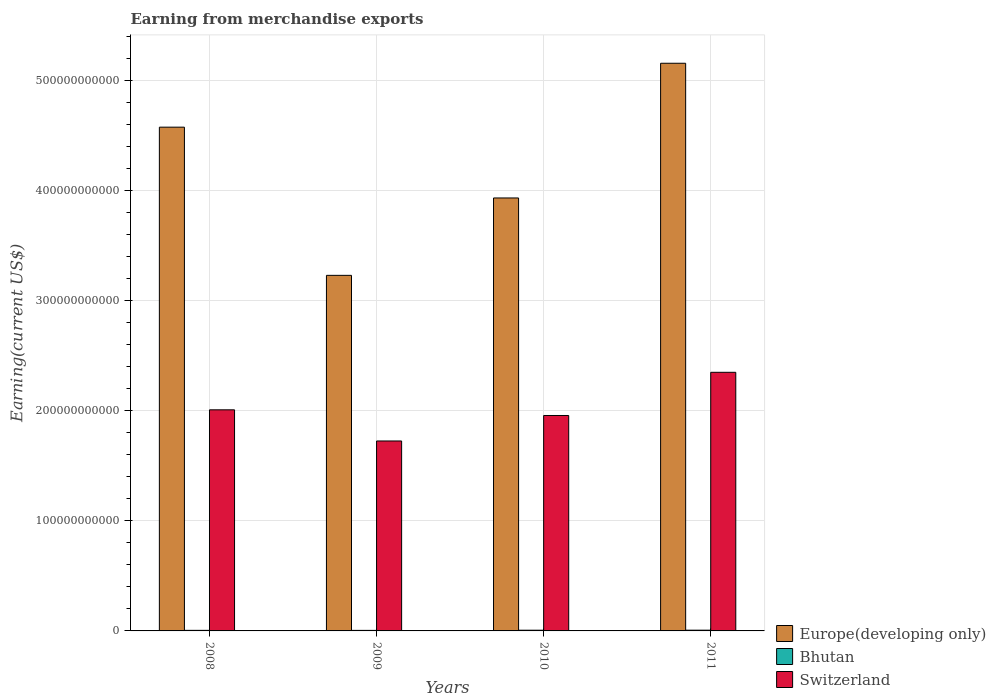Are the number of bars on each tick of the X-axis equal?
Your answer should be very brief. Yes. How many bars are there on the 2nd tick from the left?
Give a very brief answer. 3. How many bars are there on the 1st tick from the right?
Offer a terse response. 3. What is the label of the 2nd group of bars from the left?
Ensure brevity in your answer.  2009. In how many cases, is the number of bars for a given year not equal to the number of legend labels?
Keep it short and to the point. 0. What is the amount earned from merchandise exports in Europe(developing only) in 2010?
Your answer should be compact. 3.93e+11. Across all years, what is the maximum amount earned from merchandise exports in Bhutan?
Make the answer very short. 6.75e+08. Across all years, what is the minimum amount earned from merchandise exports in Bhutan?
Offer a very short reply. 4.96e+08. In which year was the amount earned from merchandise exports in Bhutan maximum?
Your answer should be compact. 2011. In which year was the amount earned from merchandise exports in Switzerland minimum?
Keep it short and to the point. 2009. What is the total amount earned from merchandise exports in Europe(developing only) in the graph?
Offer a very short reply. 1.69e+12. What is the difference between the amount earned from merchandise exports in Switzerland in 2008 and that in 2009?
Provide a succinct answer. 2.83e+1. What is the difference between the amount earned from merchandise exports in Bhutan in 2011 and the amount earned from merchandise exports in Switzerland in 2010?
Your response must be concise. -1.95e+11. What is the average amount earned from merchandise exports in Bhutan per year?
Offer a very short reply. 5.83e+08. In the year 2009, what is the difference between the amount earned from merchandise exports in Europe(developing only) and amount earned from merchandise exports in Bhutan?
Offer a terse response. 3.22e+11. In how many years, is the amount earned from merchandise exports in Europe(developing only) greater than 240000000000 US$?
Provide a short and direct response. 4. What is the ratio of the amount earned from merchandise exports in Bhutan in 2008 to that in 2009?
Offer a terse response. 1.05. What is the difference between the highest and the second highest amount earned from merchandise exports in Switzerland?
Ensure brevity in your answer.  3.41e+1. What is the difference between the highest and the lowest amount earned from merchandise exports in Europe(developing only)?
Make the answer very short. 1.93e+11. What does the 2nd bar from the left in 2008 represents?
Your answer should be compact. Bhutan. What does the 1st bar from the right in 2010 represents?
Give a very brief answer. Switzerland. How many years are there in the graph?
Your answer should be very brief. 4. What is the difference between two consecutive major ticks on the Y-axis?
Offer a very short reply. 1.00e+11. Where does the legend appear in the graph?
Provide a succinct answer. Bottom right. How many legend labels are there?
Provide a succinct answer. 3. How are the legend labels stacked?
Ensure brevity in your answer.  Vertical. What is the title of the graph?
Provide a short and direct response. Earning from merchandise exports. What is the label or title of the X-axis?
Your answer should be compact. Years. What is the label or title of the Y-axis?
Provide a short and direct response. Earning(current US$). What is the Earning(current US$) of Europe(developing only) in 2008?
Give a very brief answer. 4.57e+11. What is the Earning(current US$) in Bhutan in 2008?
Ensure brevity in your answer.  5.21e+08. What is the Earning(current US$) in Switzerland in 2008?
Your answer should be compact. 2.01e+11. What is the Earning(current US$) of Europe(developing only) in 2009?
Keep it short and to the point. 3.23e+11. What is the Earning(current US$) in Bhutan in 2009?
Offer a terse response. 4.96e+08. What is the Earning(current US$) in Switzerland in 2009?
Offer a very short reply. 1.72e+11. What is the Earning(current US$) in Europe(developing only) in 2010?
Your answer should be very brief. 3.93e+11. What is the Earning(current US$) of Bhutan in 2010?
Offer a very short reply. 6.41e+08. What is the Earning(current US$) in Switzerland in 2010?
Your answer should be compact. 1.96e+11. What is the Earning(current US$) in Europe(developing only) in 2011?
Provide a succinct answer. 5.15e+11. What is the Earning(current US$) of Bhutan in 2011?
Provide a short and direct response. 6.75e+08. What is the Earning(current US$) in Switzerland in 2011?
Ensure brevity in your answer.  2.35e+11. Across all years, what is the maximum Earning(current US$) of Europe(developing only)?
Your answer should be compact. 5.15e+11. Across all years, what is the maximum Earning(current US$) of Bhutan?
Give a very brief answer. 6.75e+08. Across all years, what is the maximum Earning(current US$) of Switzerland?
Provide a short and direct response. 2.35e+11. Across all years, what is the minimum Earning(current US$) in Europe(developing only)?
Your answer should be compact. 3.23e+11. Across all years, what is the minimum Earning(current US$) in Bhutan?
Offer a terse response. 4.96e+08. Across all years, what is the minimum Earning(current US$) in Switzerland?
Provide a short and direct response. 1.72e+11. What is the total Earning(current US$) of Europe(developing only) in the graph?
Offer a terse response. 1.69e+12. What is the total Earning(current US$) of Bhutan in the graph?
Your answer should be compact. 2.33e+09. What is the total Earning(current US$) of Switzerland in the graph?
Give a very brief answer. 8.04e+11. What is the difference between the Earning(current US$) in Europe(developing only) in 2008 and that in 2009?
Ensure brevity in your answer.  1.35e+11. What is the difference between the Earning(current US$) of Bhutan in 2008 and that in 2009?
Your answer should be compact. 2.56e+07. What is the difference between the Earning(current US$) of Switzerland in 2008 and that in 2009?
Your response must be concise. 2.83e+1. What is the difference between the Earning(current US$) in Europe(developing only) in 2008 and that in 2010?
Provide a succinct answer. 6.43e+1. What is the difference between the Earning(current US$) of Bhutan in 2008 and that in 2010?
Provide a short and direct response. -1.20e+08. What is the difference between the Earning(current US$) of Switzerland in 2008 and that in 2010?
Keep it short and to the point. 5.15e+09. What is the difference between the Earning(current US$) in Europe(developing only) in 2008 and that in 2011?
Ensure brevity in your answer.  -5.80e+1. What is the difference between the Earning(current US$) of Bhutan in 2008 and that in 2011?
Give a very brief answer. -1.53e+08. What is the difference between the Earning(current US$) of Switzerland in 2008 and that in 2011?
Make the answer very short. -3.41e+1. What is the difference between the Earning(current US$) of Europe(developing only) in 2009 and that in 2010?
Provide a succinct answer. -7.03e+1. What is the difference between the Earning(current US$) of Bhutan in 2009 and that in 2010?
Make the answer very short. -1.45e+08. What is the difference between the Earning(current US$) of Switzerland in 2009 and that in 2010?
Keep it short and to the point. -2.31e+1. What is the difference between the Earning(current US$) in Europe(developing only) in 2009 and that in 2011?
Keep it short and to the point. -1.93e+11. What is the difference between the Earning(current US$) in Bhutan in 2009 and that in 2011?
Your answer should be very brief. -1.79e+08. What is the difference between the Earning(current US$) of Switzerland in 2009 and that in 2011?
Give a very brief answer. -6.23e+1. What is the difference between the Earning(current US$) of Europe(developing only) in 2010 and that in 2011?
Provide a succinct answer. -1.22e+11. What is the difference between the Earning(current US$) in Bhutan in 2010 and that in 2011?
Provide a short and direct response. -3.33e+07. What is the difference between the Earning(current US$) of Switzerland in 2010 and that in 2011?
Provide a short and direct response. -3.92e+1. What is the difference between the Earning(current US$) of Europe(developing only) in 2008 and the Earning(current US$) of Bhutan in 2009?
Keep it short and to the point. 4.57e+11. What is the difference between the Earning(current US$) in Europe(developing only) in 2008 and the Earning(current US$) in Switzerland in 2009?
Your response must be concise. 2.85e+11. What is the difference between the Earning(current US$) in Bhutan in 2008 and the Earning(current US$) in Switzerland in 2009?
Make the answer very short. -1.72e+11. What is the difference between the Earning(current US$) in Europe(developing only) in 2008 and the Earning(current US$) in Bhutan in 2010?
Offer a very short reply. 4.57e+11. What is the difference between the Earning(current US$) of Europe(developing only) in 2008 and the Earning(current US$) of Switzerland in 2010?
Your answer should be very brief. 2.62e+11. What is the difference between the Earning(current US$) of Bhutan in 2008 and the Earning(current US$) of Switzerland in 2010?
Your answer should be compact. -1.95e+11. What is the difference between the Earning(current US$) of Europe(developing only) in 2008 and the Earning(current US$) of Bhutan in 2011?
Offer a very short reply. 4.57e+11. What is the difference between the Earning(current US$) in Europe(developing only) in 2008 and the Earning(current US$) in Switzerland in 2011?
Provide a short and direct response. 2.23e+11. What is the difference between the Earning(current US$) of Bhutan in 2008 and the Earning(current US$) of Switzerland in 2011?
Keep it short and to the point. -2.34e+11. What is the difference between the Earning(current US$) in Europe(developing only) in 2009 and the Earning(current US$) in Bhutan in 2010?
Give a very brief answer. 3.22e+11. What is the difference between the Earning(current US$) in Europe(developing only) in 2009 and the Earning(current US$) in Switzerland in 2010?
Offer a terse response. 1.27e+11. What is the difference between the Earning(current US$) of Bhutan in 2009 and the Earning(current US$) of Switzerland in 2010?
Your answer should be very brief. -1.95e+11. What is the difference between the Earning(current US$) in Europe(developing only) in 2009 and the Earning(current US$) in Bhutan in 2011?
Your answer should be very brief. 3.22e+11. What is the difference between the Earning(current US$) in Europe(developing only) in 2009 and the Earning(current US$) in Switzerland in 2011?
Offer a very short reply. 8.80e+1. What is the difference between the Earning(current US$) in Bhutan in 2009 and the Earning(current US$) in Switzerland in 2011?
Keep it short and to the point. -2.34e+11. What is the difference between the Earning(current US$) of Europe(developing only) in 2010 and the Earning(current US$) of Bhutan in 2011?
Keep it short and to the point. 3.92e+11. What is the difference between the Earning(current US$) in Europe(developing only) in 2010 and the Earning(current US$) in Switzerland in 2011?
Keep it short and to the point. 1.58e+11. What is the difference between the Earning(current US$) in Bhutan in 2010 and the Earning(current US$) in Switzerland in 2011?
Offer a very short reply. -2.34e+11. What is the average Earning(current US$) in Europe(developing only) per year?
Make the answer very short. 4.22e+11. What is the average Earning(current US$) in Bhutan per year?
Make the answer very short. 5.83e+08. What is the average Earning(current US$) in Switzerland per year?
Provide a short and direct response. 2.01e+11. In the year 2008, what is the difference between the Earning(current US$) in Europe(developing only) and Earning(current US$) in Bhutan?
Keep it short and to the point. 4.57e+11. In the year 2008, what is the difference between the Earning(current US$) in Europe(developing only) and Earning(current US$) in Switzerland?
Your answer should be compact. 2.57e+11. In the year 2008, what is the difference between the Earning(current US$) in Bhutan and Earning(current US$) in Switzerland?
Offer a terse response. -2.00e+11. In the year 2009, what is the difference between the Earning(current US$) in Europe(developing only) and Earning(current US$) in Bhutan?
Provide a succinct answer. 3.22e+11. In the year 2009, what is the difference between the Earning(current US$) in Europe(developing only) and Earning(current US$) in Switzerland?
Offer a terse response. 1.50e+11. In the year 2009, what is the difference between the Earning(current US$) in Bhutan and Earning(current US$) in Switzerland?
Make the answer very short. -1.72e+11. In the year 2010, what is the difference between the Earning(current US$) in Europe(developing only) and Earning(current US$) in Bhutan?
Ensure brevity in your answer.  3.92e+11. In the year 2010, what is the difference between the Earning(current US$) in Europe(developing only) and Earning(current US$) in Switzerland?
Keep it short and to the point. 1.98e+11. In the year 2010, what is the difference between the Earning(current US$) in Bhutan and Earning(current US$) in Switzerland?
Your response must be concise. -1.95e+11. In the year 2011, what is the difference between the Earning(current US$) of Europe(developing only) and Earning(current US$) of Bhutan?
Keep it short and to the point. 5.15e+11. In the year 2011, what is the difference between the Earning(current US$) in Europe(developing only) and Earning(current US$) in Switzerland?
Keep it short and to the point. 2.81e+11. In the year 2011, what is the difference between the Earning(current US$) of Bhutan and Earning(current US$) of Switzerland?
Your answer should be very brief. -2.34e+11. What is the ratio of the Earning(current US$) in Europe(developing only) in 2008 to that in 2009?
Your response must be concise. 1.42. What is the ratio of the Earning(current US$) of Bhutan in 2008 to that in 2009?
Give a very brief answer. 1.05. What is the ratio of the Earning(current US$) of Switzerland in 2008 to that in 2009?
Your answer should be compact. 1.16. What is the ratio of the Earning(current US$) of Europe(developing only) in 2008 to that in 2010?
Keep it short and to the point. 1.16. What is the ratio of the Earning(current US$) of Bhutan in 2008 to that in 2010?
Offer a very short reply. 0.81. What is the ratio of the Earning(current US$) of Switzerland in 2008 to that in 2010?
Make the answer very short. 1.03. What is the ratio of the Earning(current US$) in Europe(developing only) in 2008 to that in 2011?
Offer a terse response. 0.89. What is the ratio of the Earning(current US$) in Bhutan in 2008 to that in 2011?
Provide a short and direct response. 0.77. What is the ratio of the Earning(current US$) in Switzerland in 2008 to that in 2011?
Make the answer very short. 0.85. What is the ratio of the Earning(current US$) of Europe(developing only) in 2009 to that in 2010?
Make the answer very short. 0.82. What is the ratio of the Earning(current US$) of Bhutan in 2009 to that in 2010?
Ensure brevity in your answer.  0.77. What is the ratio of the Earning(current US$) in Switzerland in 2009 to that in 2010?
Make the answer very short. 0.88. What is the ratio of the Earning(current US$) in Europe(developing only) in 2009 to that in 2011?
Your response must be concise. 0.63. What is the ratio of the Earning(current US$) of Bhutan in 2009 to that in 2011?
Give a very brief answer. 0.73. What is the ratio of the Earning(current US$) in Switzerland in 2009 to that in 2011?
Keep it short and to the point. 0.73. What is the ratio of the Earning(current US$) of Europe(developing only) in 2010 to that in 2011?
Provide a short and direct response. 0.76. What is the ratio of the Earning(current US$) in Bhutan in 2010 to that in 2011?
Provide a succinct answer. 0.95. What is the ratio of the Earning(current US$) of Switzerland in 2010 to that in 2011?
Offer a terse response. 0.83. What is the difference between the highest and the second highest Earning(current US$) of Europe(developing only)?
Provide a short and direct response. 5.80e+1. What is the difference between the highest and the second highest Earning(current US$) of Bhutan?
Your answer should be compact. 3.33e+07. What is the difference between the highest and the second highest Earning(current US$) in Switzerland?
Your answer should be very brief. 3.41e+1. What is the difference between the highest and the lowest Earning(current US$) of Europe(developing only)?
Ensure brevity in your answer.  1.93e+11. What is the difference between the highest and the lowest Earning(current US$) of Bhutan?
Ensure brevity in your answer.  1.79e+08. What is the difference between the highest and the lowest Earning(current US$) in Switzerland?
Ensure brevity in your answer.  6.23e+1. 